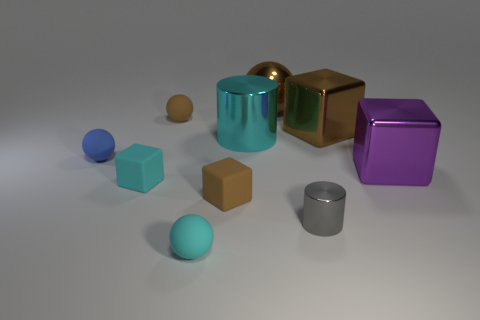What materials do the objects in the image seem to be made of? The objects in the image exhibit different textures and reflections suggesting a variety of materials. The spheres and cubes have a matte or slightly reflective surface indicative of plastic or painted metal. Meanwhile, the cylinder and the cube with a reflective surface could be made of polished metal or chrome, given their shiny appearance that reflects the environment. 